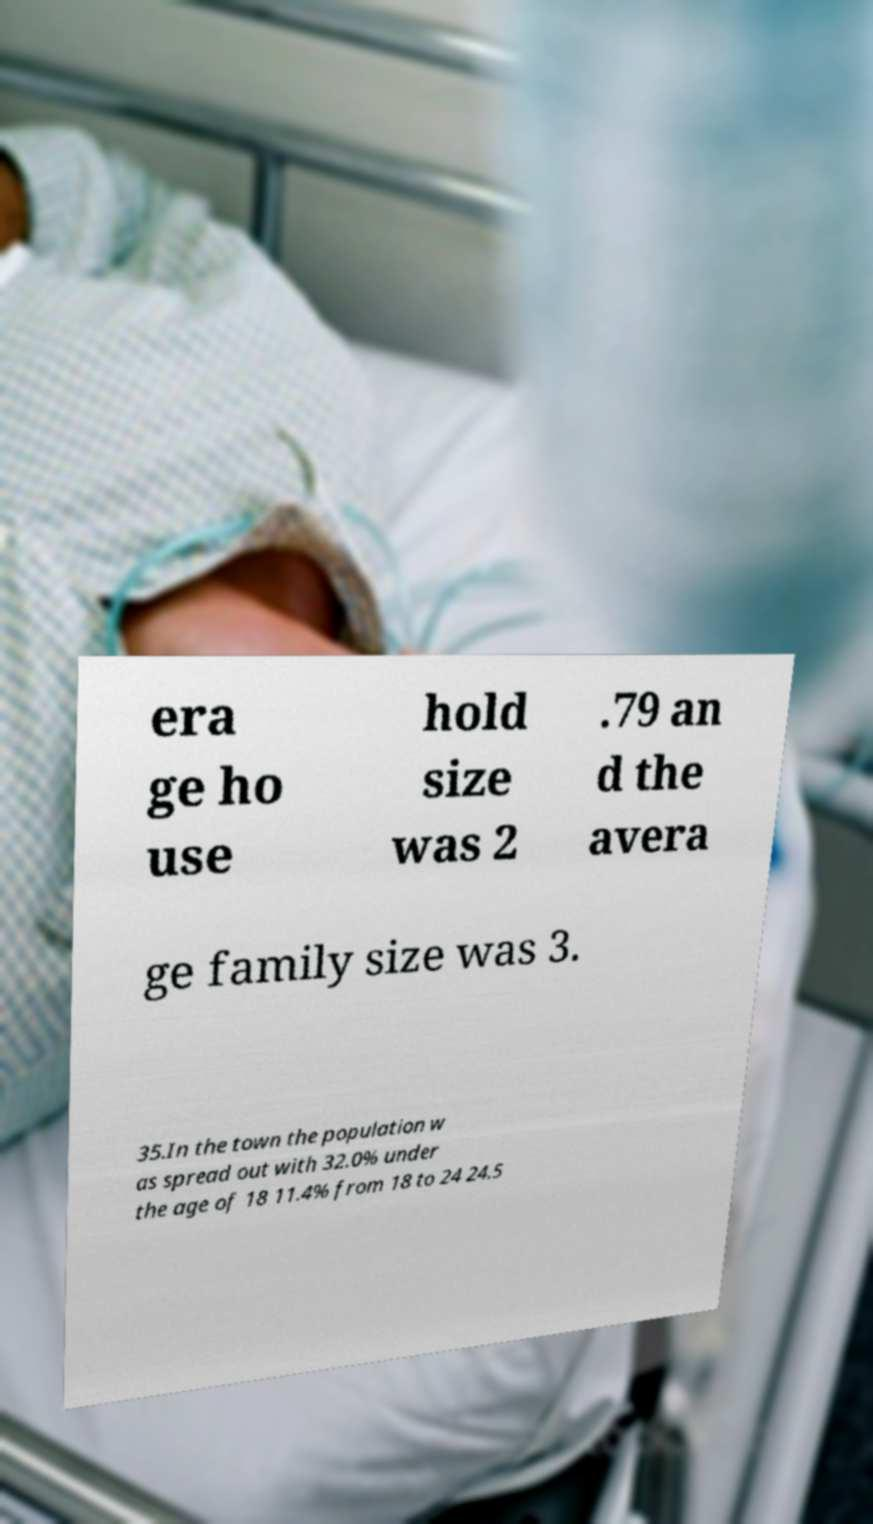Please read and relay the text visible in this image. What does it say? era ge ho use hold size was 2 .79 an d the avera ge family size was 3. 35.In the town the population w as spread out with 32.0% under the age of 18 11.4% from 18 to 24 24.5 